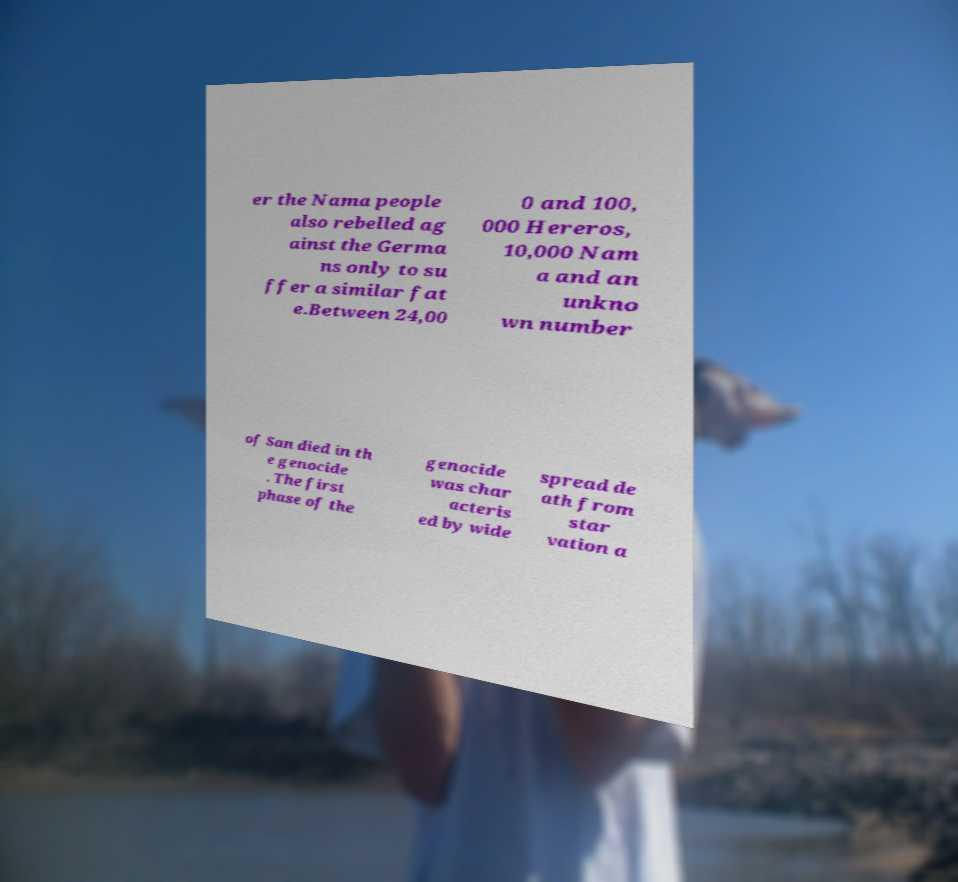What messages or text are displayed in this image? I need them in a readable, typed format. er the Nama people also rebelled ag ainst the Germa ns only to su ffer a similar fat e.Between 24,00 0 and 100, 000 Hereros, 10,000 Nam a and an unkno wn number of San died in th e genocide . The first phase of the genocide was char acteris ed by wide spread de ath from star vation a 